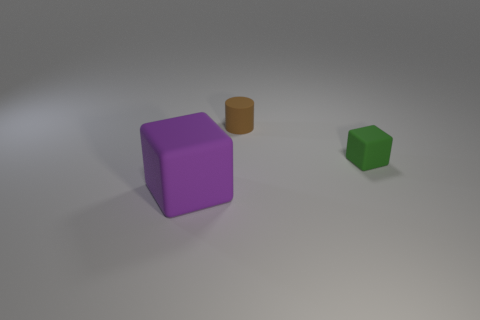What might be the purpose of the three differently sized and colored objects in this image? The three objects are likely used to illustrate concepts such as comparison of size, color differentiation, or spatial awareness. They could have educational purposes, for instance in teaching geometry or colors, or they might simply be depicted for a visual demonstration in a digital modeling context. 